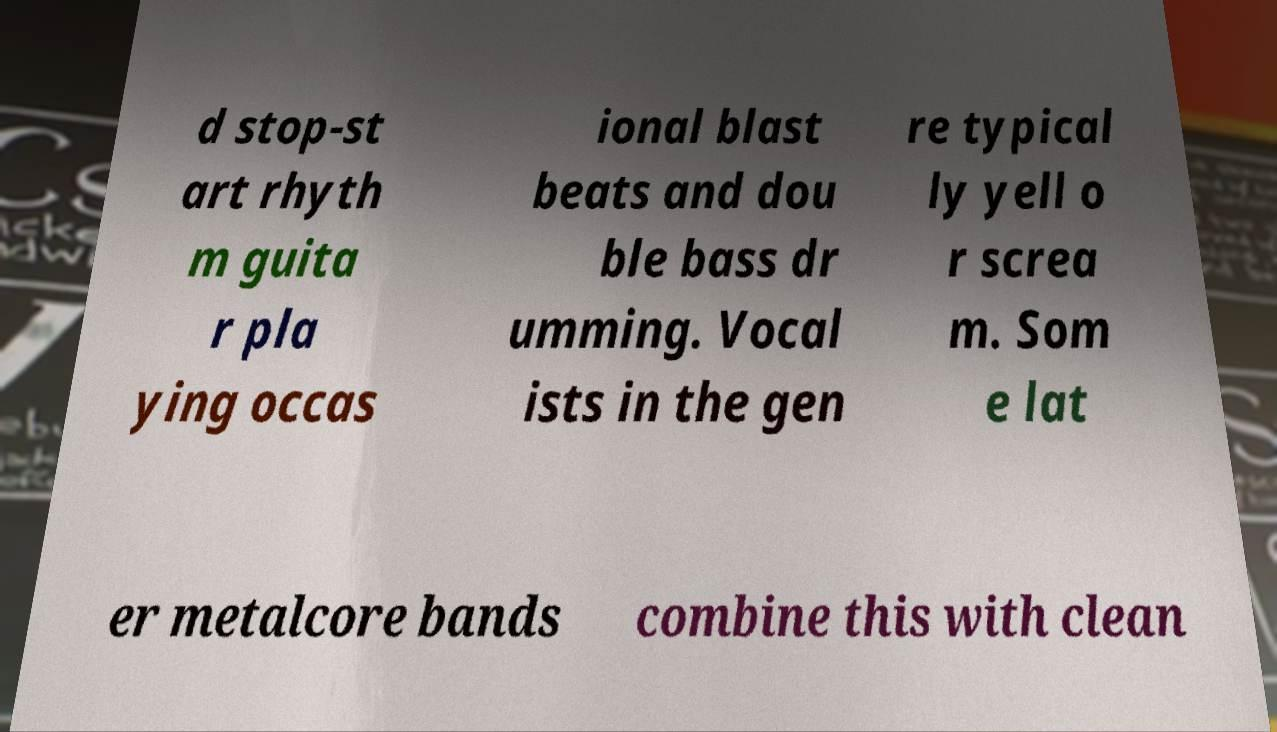Can you accurately transcribe the text from the provided image for me? d stop-st art rhyth m guita r pla ying occas ional blast beats and dou ble bass dr umming. Vocal ists in the gen re typical ly yell o r screa m. Som e lat er metalcore bands combine this with clean 